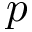Convert formula to latex. <formula><loc_0><loc_0><loc_500><loc_500>p</formula> 